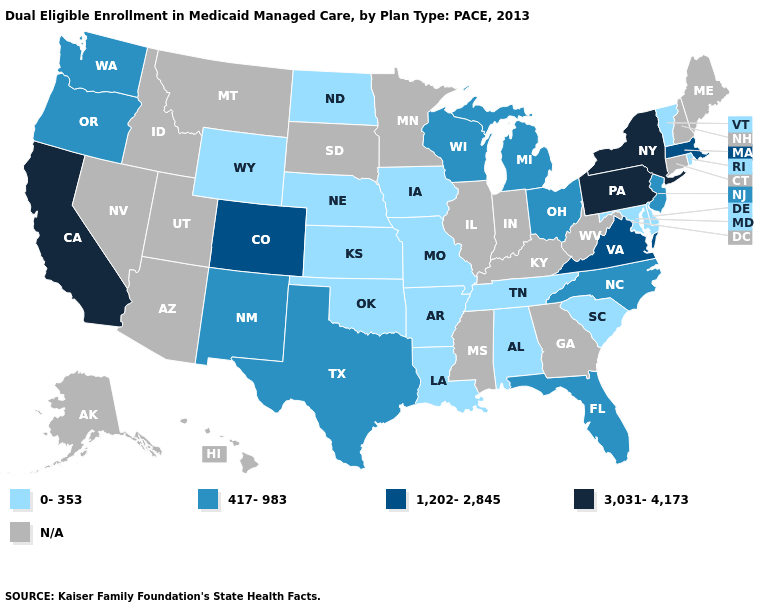Does the map have missing data?
Answer briefly. Yes. Among the states that border Ohio , does Pennsylvania have the highest value?
Short answer required. Yes. Which states hav the highest value in the South?
Write a very short answer. Virginia. Among the states that border Maryland , which have the highest value?
Be succinct. Pennsylvania. What is the lowest value in the Northeast?
Write a very short answer. 0-353. Which states have the lowest value in the USA?
Keep it brief. Alabama, Arkansas, Delaware, Iowa, Kansas, Louisiana, Maryland, Missouri, Nebraska, North Dakota, Oklahoma, Rhode Island, South Carolina, Tennessee, Vermont, Wyoming. What is the value of Vermont?
Concise answer only. 0-353. Among the states that border New Jersey , does New York have the lowest value?
Give a very brief answer. No. What is the highest value in the West ?
Short answer required. 3,031-4,173. Does Ohio have the highest value in the MidWest?
Answer briefly. Yes. What is the highest value in states that border Vermont?
Write a very short answer. 3,031-4,173. How many symbols are there in the legend?
Keep it brief. 5. 